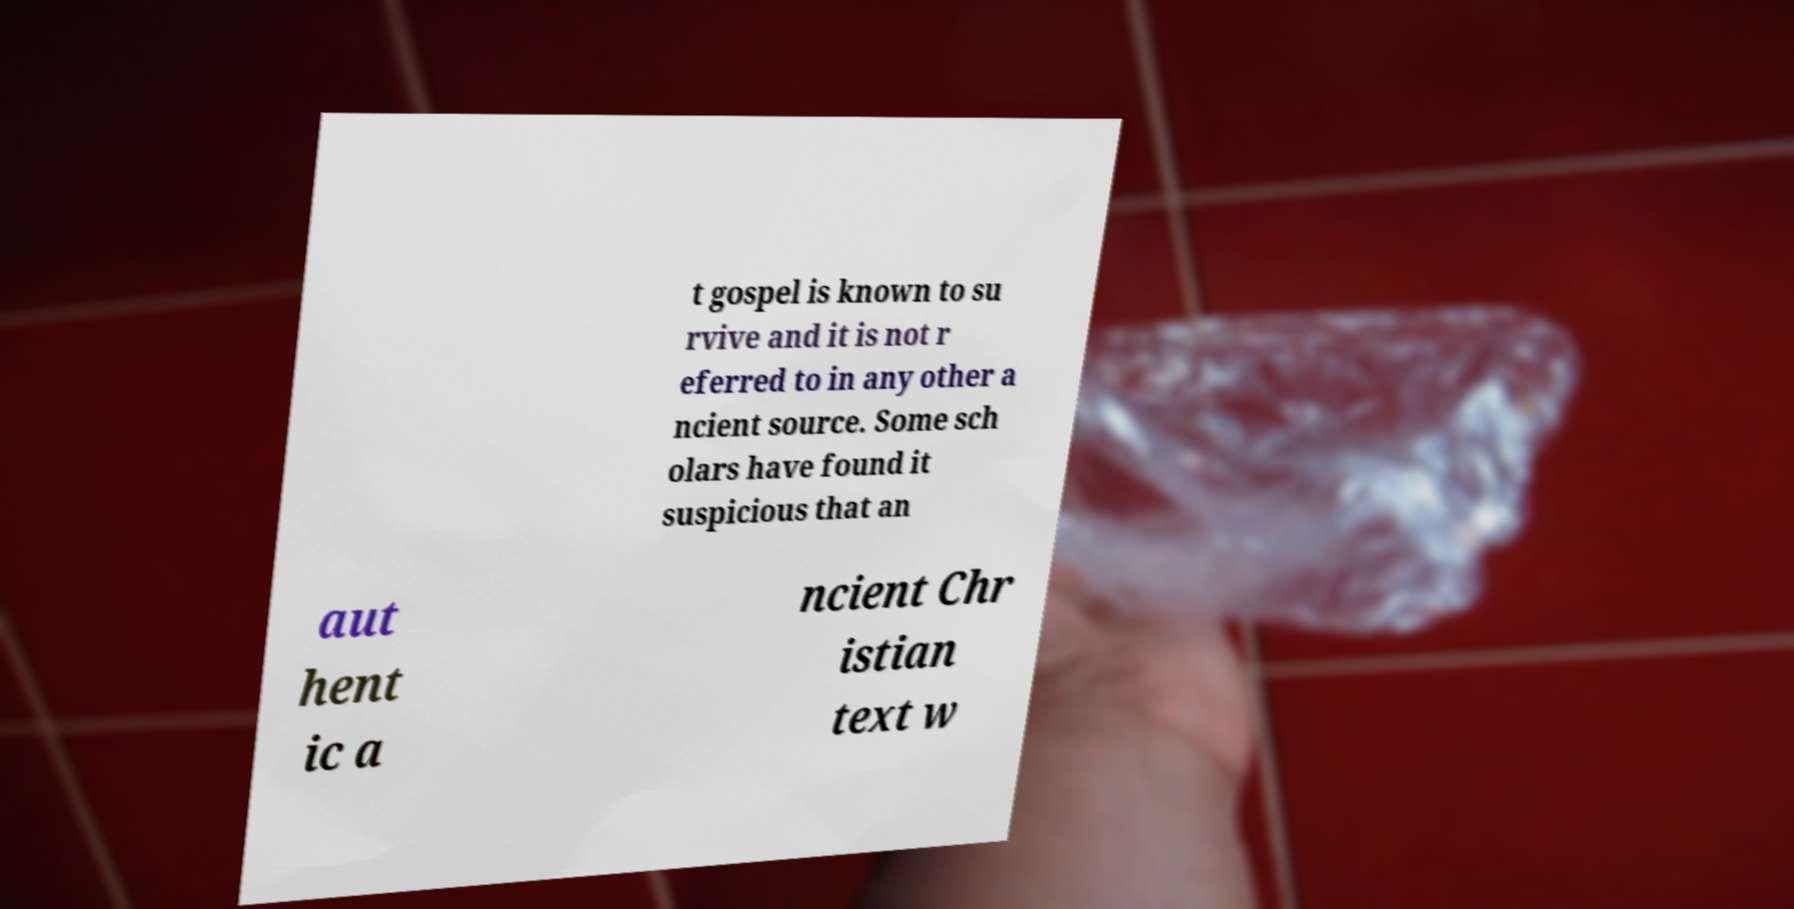Could you extract and type out the text from this image? t gospel is known to su rvive and it is not r eferred to in any other a ncient source. Some sch olars have found it suspicious that an aut hent ic a ncient Chr istian text w 